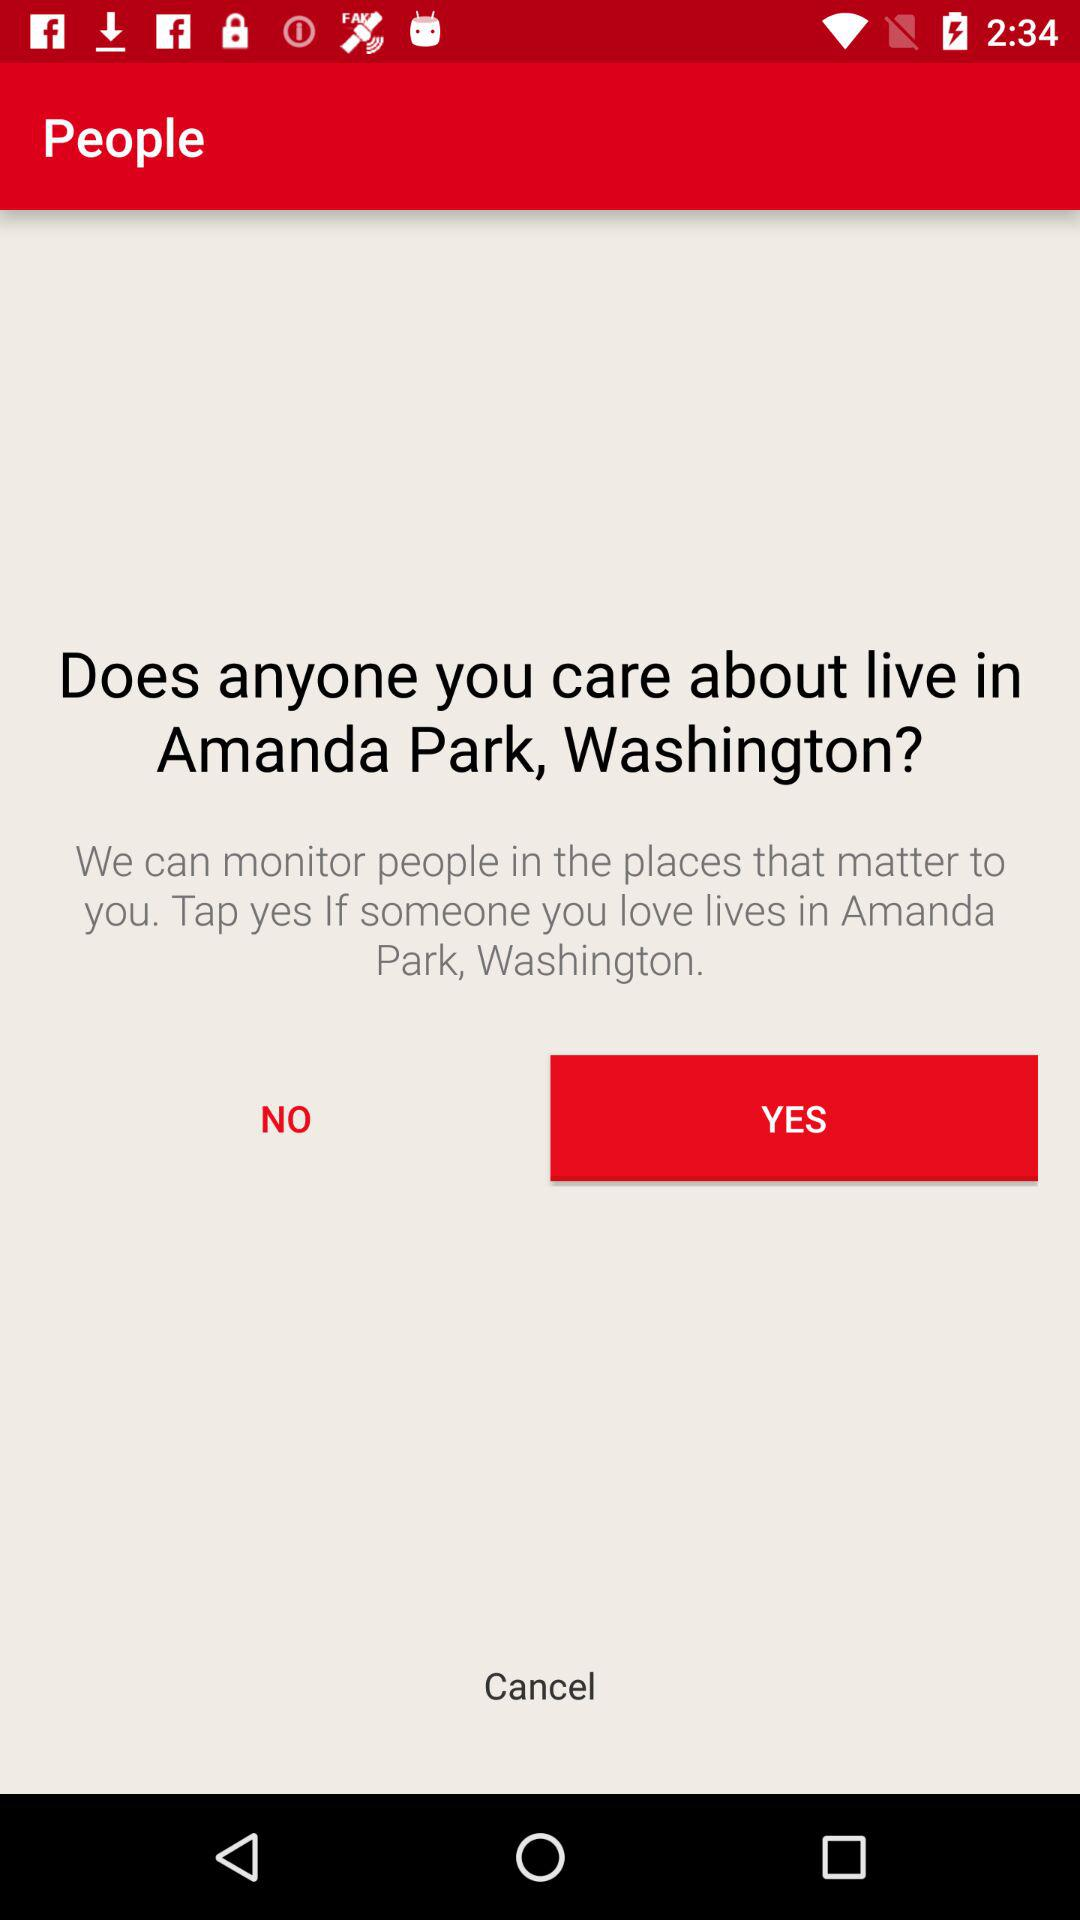What is the location? The location is Amanda Park, Washington. 